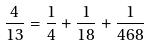Convert formula to latex. <formula><loc_0><loc_0><loc_500><loc_500>\frac { 4 } { 1 3 } = \frac { 1 } { 4 } + \frac { 1 } { 1 8 } + \frac { 1 } { 4 6 8 }</formula> 